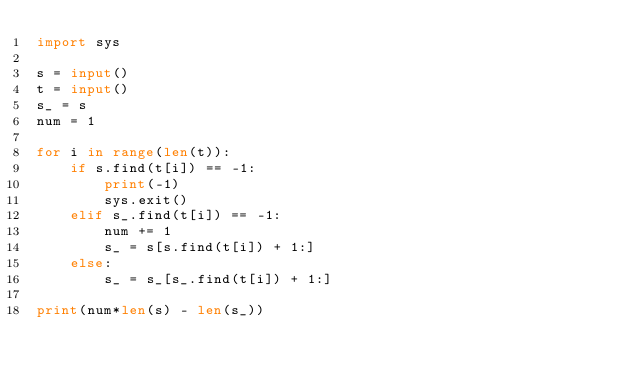Convert code to text. <code><loc_0><loc_0><loc_500><loc_500><_Python_>import sys

s = input()
t = input()
s_ = s
num = 1

for i in range(len(t)):
    if s.find(t[i]) == -1:
        print(-1)
        sys.exit()
    elif s_.find(t[i]) == -1:
        num += 1
        s_ = s[s.find(t[i]) + 1:]
    else:
        s_ = s_[s_.find(t[i]) + 1:]

print(num*len(s) - len(s_))</code> 